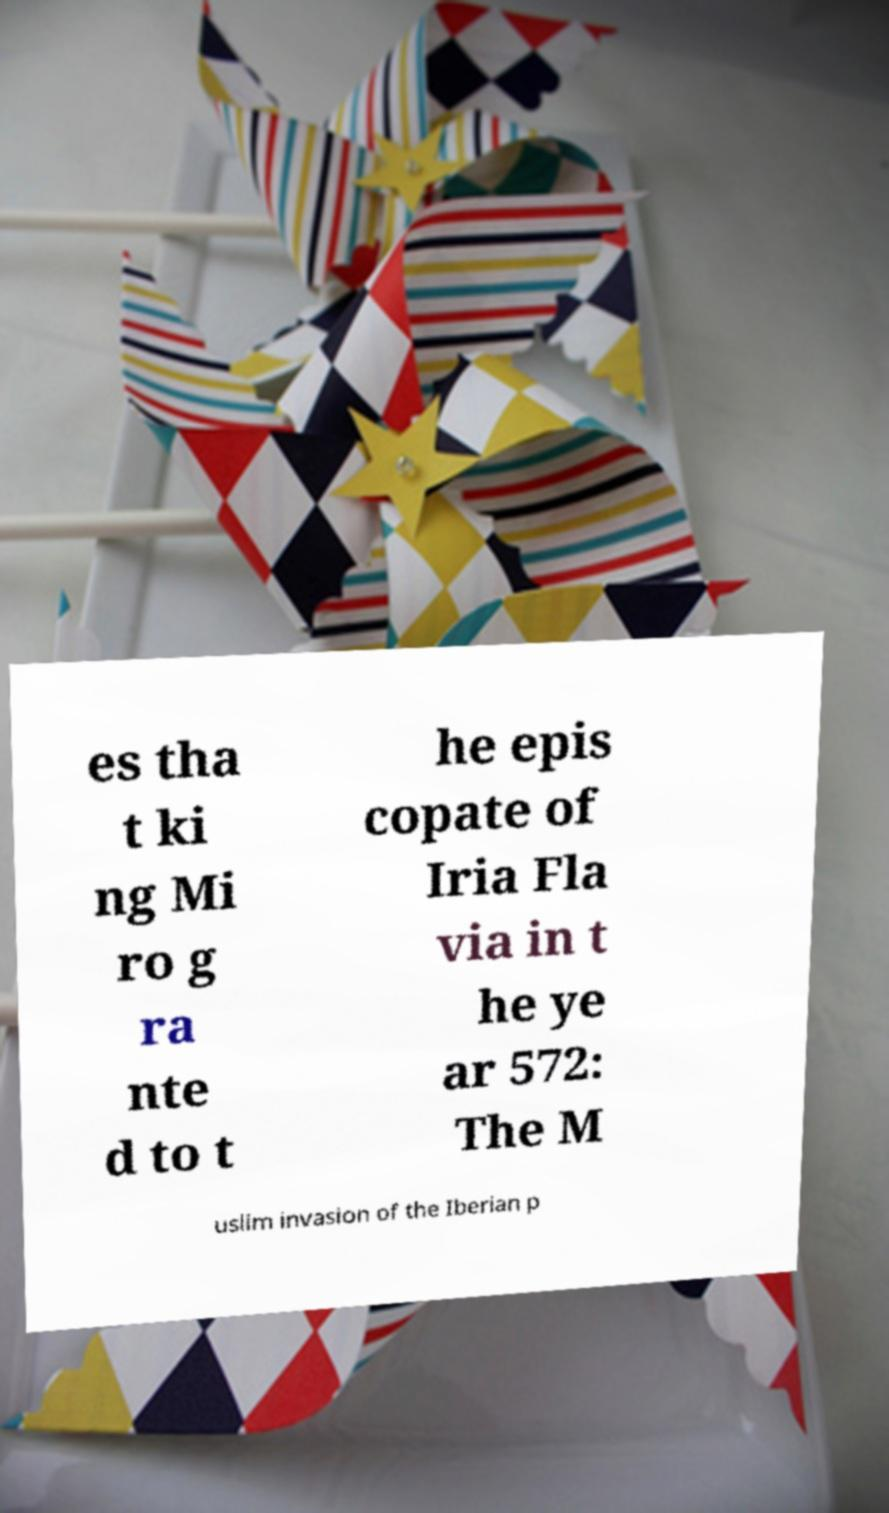Can you read and provide the text displayed in the image?This photo seems to have some interesting text. Can you extract and type it out for me? es tha t ki ng Mi ro g ra nte d to t he epis copate of Iria Fla via in t he ye ar 572: The M uslim invasion of the Iberian p 